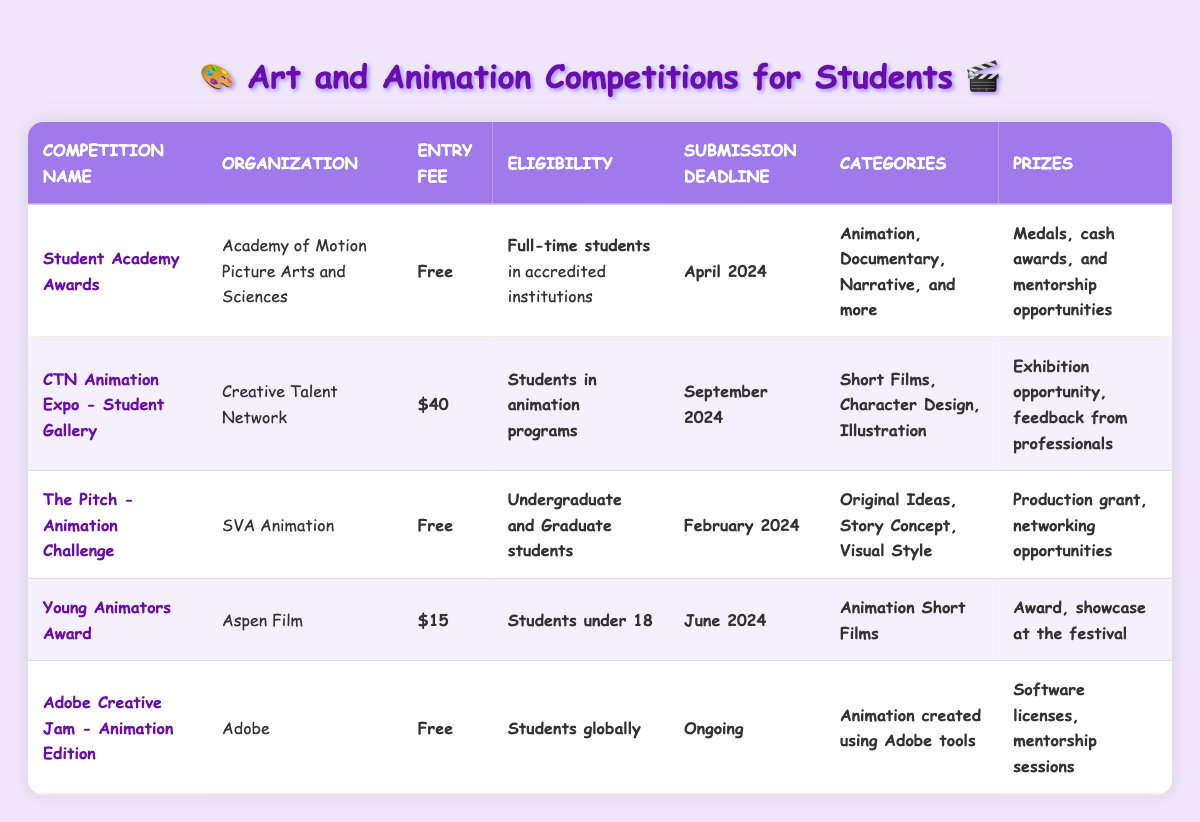What is the entry fee for the Student Academy Awards? The entry fee for the Student Academy Awards is clearly stated in the table as **Free**.
Answer: Free Who is eligible to enter the Young Animators Award? The eligibility criteria for the Young Animators Award specifically mention that it is for **Students under 18**.
Answer: Students under 18 What are the categories available in the CTN Animation Expo - Student Gallery? The categories for the CTN Animation Expo - Student Gallery are listed as **Short Films, Character Design, Illustration** in the table.
Answer: Short Films, Character Design, Illustration How many competitions have a submission deadline before June 2024? The competitions with submission deadlines before June 2024 are: Student Academy Awards (April 2024), The Pitch (February 2024), and Young Animators Award (June 2024). Counting these gives 3 competitions before June 2024.
Answer: 3 What is the submission deadline for the Adobe Creative Jam - Animation Edition? The table states that the submission deadline for the Adobe Creative Jam - Animation Edition is **Ongoing**, indicating that there is no specific end date for entries.
Answer: Ongoing Which competition provides feedback from professionals as a prize? Referring to the table, the CTN Animation Expo - Student Gallery offers **Exhibition opportunity, feedback from professionals** as part of its prize.
Answer: CTN Animation Expo - Student Gallery How many competitions have an entry fee and what is the total of those fees? The competitions that have an entry fee are: CTN Animation Expo ($40), Young Animators Award ($15). Summing these fees gives $40 + $15 = $55.
Answer: $55 Is the Student Academy Awards open to all students or only certain types? According to the table, the Student Academy Awards are exclusively for **Full-time students** in accredited institutions, not open to all students.
Answer: No What are the prizes offered by the Pitch - Animation Challenge? The prizes for the Pitch - Animation Challenge include **Production grant, networking opportunities** as described in the table.
Answer: Production grant, networking opportunities Which competition has the earliest submission deadline and what is it? Among the listed competitions, The Pitch - Animation Challenge has the earliest submission deadline of **February 2024**, as seen in the table.
Answer: February 2024 